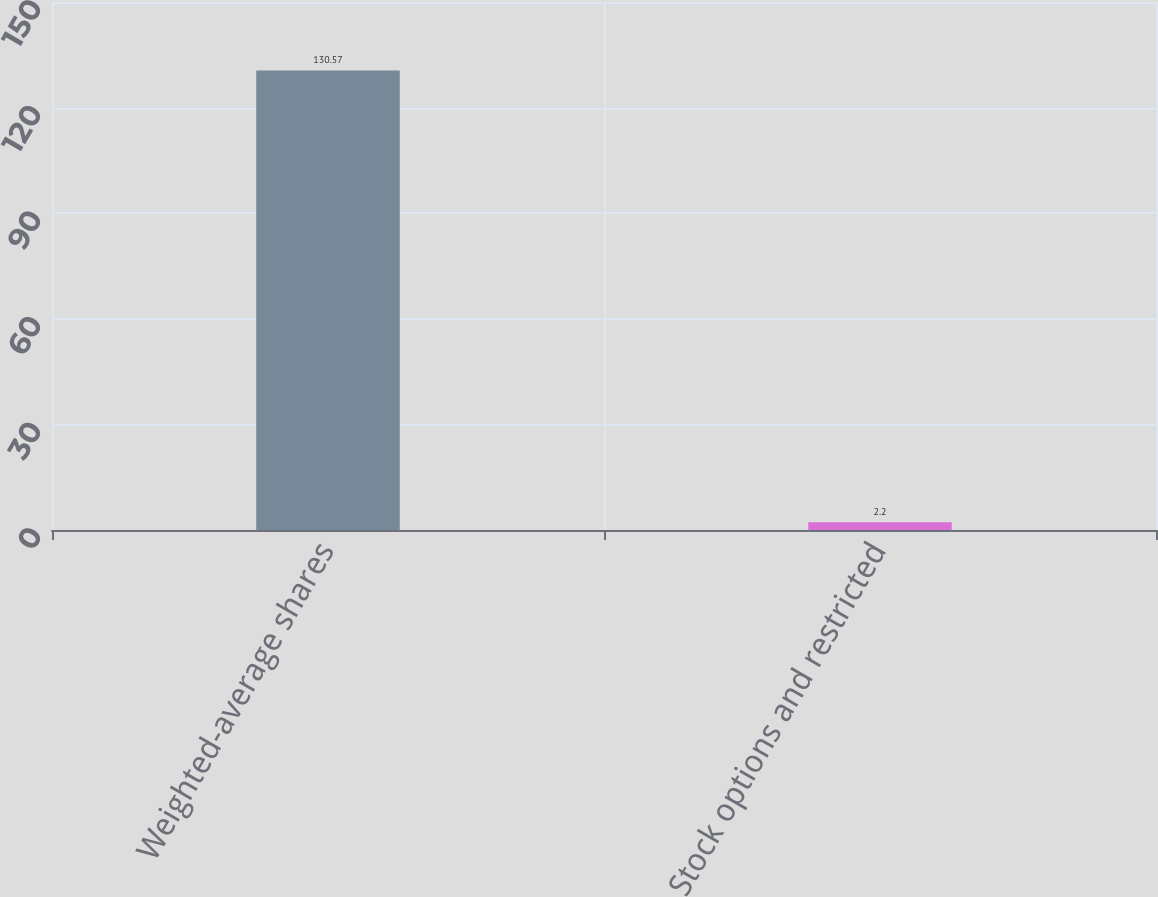Convert chart. <chart><loc_0><loc_0><loc_500><loc_500><bar_chart><fcel>Weighted-average shares<fcel>Stock options and restricted<nl><fcel>130.57<fcel>2.2<nl></chart> 